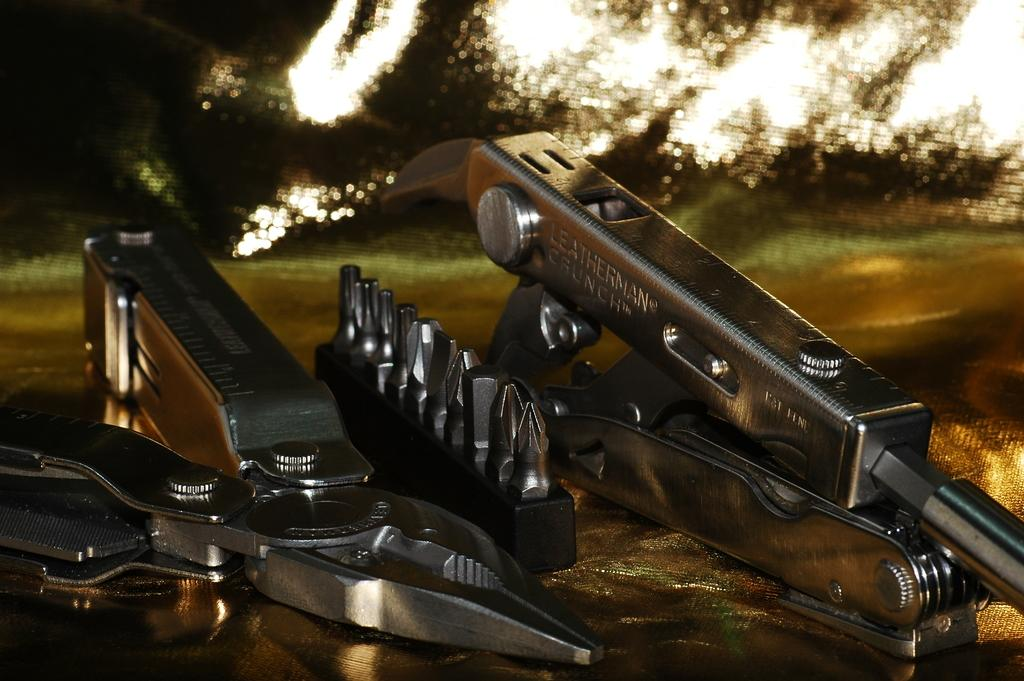What tool is on the floor in the image? There is a cutting plier on the floor in the image. What is located beside the cutting plier? There is an object beside the cutting plier. Can you describe the object beside the cutting plier? The object has text on it. How would you describe the overall appearance of the image? The background of the image is blurry. What type of shade is being discussed by the committee in the image? There is no committee or shade present in the image; it features a cutting plier and an object with text on it. 